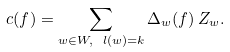Convert formula to latex. <formula><loc_0><loc_0><loc_500><loc_500>c ( f ) = \sum _ { w \in W , \ l ( w ) = k } \Delta _ { w } ( f ) \, Z _ { w } .</formula> 